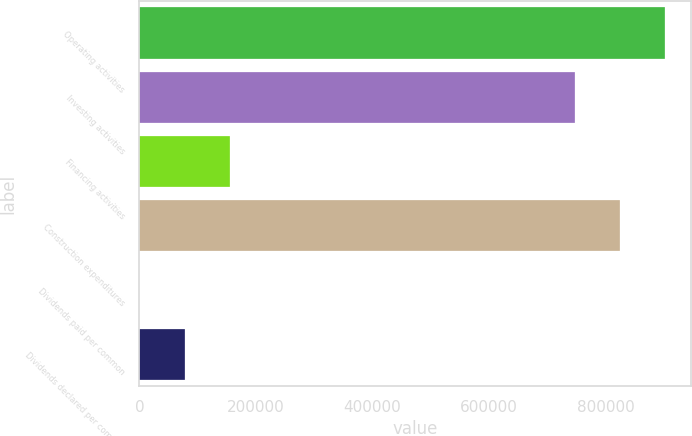Convert chart to OTSL. <chart><loc_0><loc_0><loc_500><loc_500><bar_chart><fcel>Operating activities<fcel>Investing activities<fcel>Financing activities<fcel>Construction expenditures<fcel>Dividends paid per common<fcel>Dividends declared per common<nl><fcel>901729<fcel>746743<fcel>154987<fcel>824236<fcel>0.86<fcel>77494.1<nl></chart> 